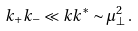Convert formula to latex. <formula><loc_0><loc_0><loc_500><loc_500>k _ { + } k _ { - } \ll k k ^ { * } \sim \mu ^ { 2 } _ { \bot } \, .</formula> 